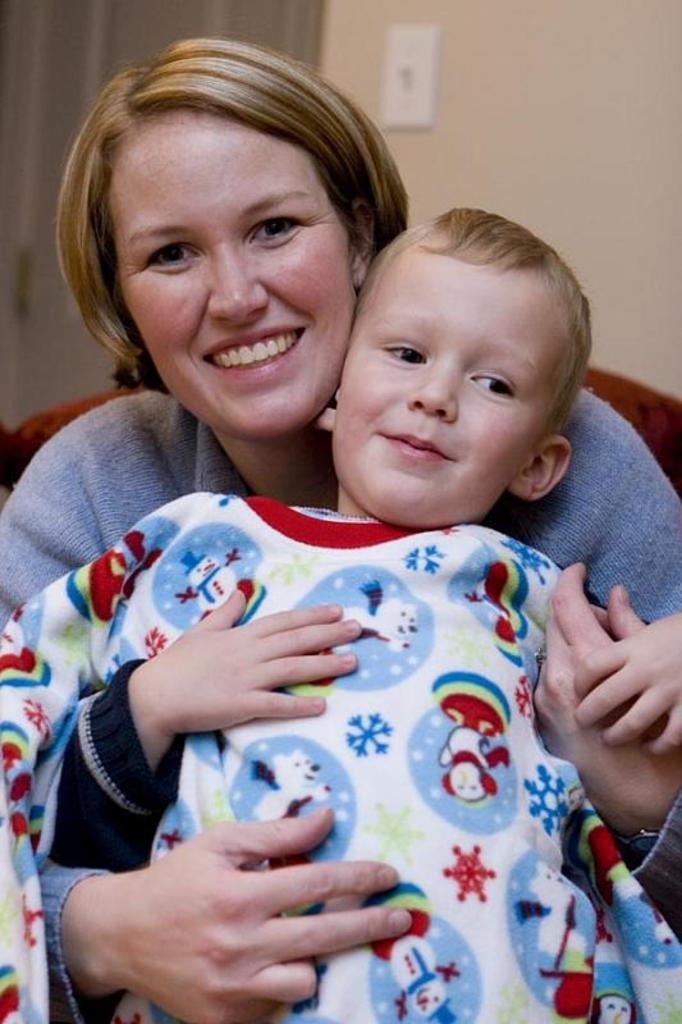What is the hair color of the woman in the image? The woman in the image has blond hair. What is the woman wearing in the image? The woman is wearing a grey dress. What is the woman doing in the image? The woman is holding a boy in the image. What can be seen in the background of the image? There is a wall in the background of the image. What type of sack can be seen hanging on the wall in the image? There is no sack present in the image; the background only features a wall. 